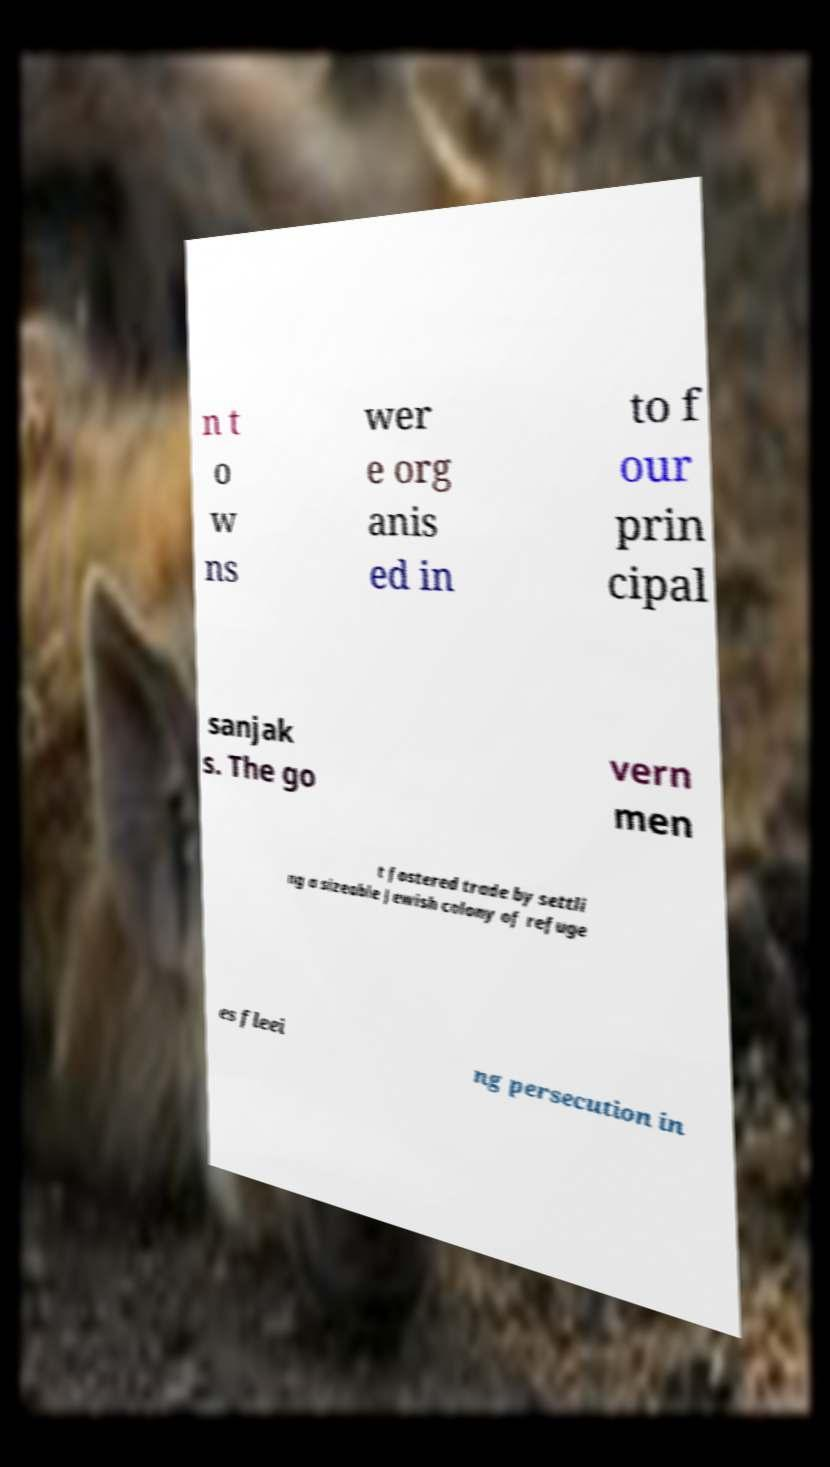Can you accurately transcribe the text from the provided image for me? n t o w ns wer e org anis ed in to f our prin cipal sanjak s. The go vern men t fostered trade by settli ng a sizeable Jewish colony of refuge es fleei ng persecution in 